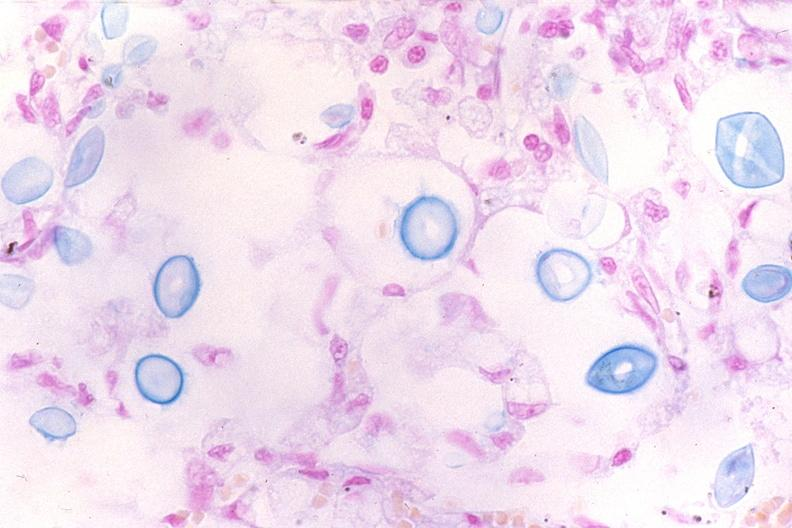s respiratory present?
Answer the question using a single word or phrase. Yes 